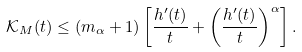Convert formula to latex. <formula><loc_0><loc_0><loc_500><loc_500>\mathcal { K } _ { M } ( t ) \leq ( m _ { \alpha } + 1 ) \left [ \frac { h ^ { \prime } ( t ) } { t } + \left ( \frac { h ^ { \prime } ( t ) } { t } \right ) ^ { \alpha } \right ] .</formula> 